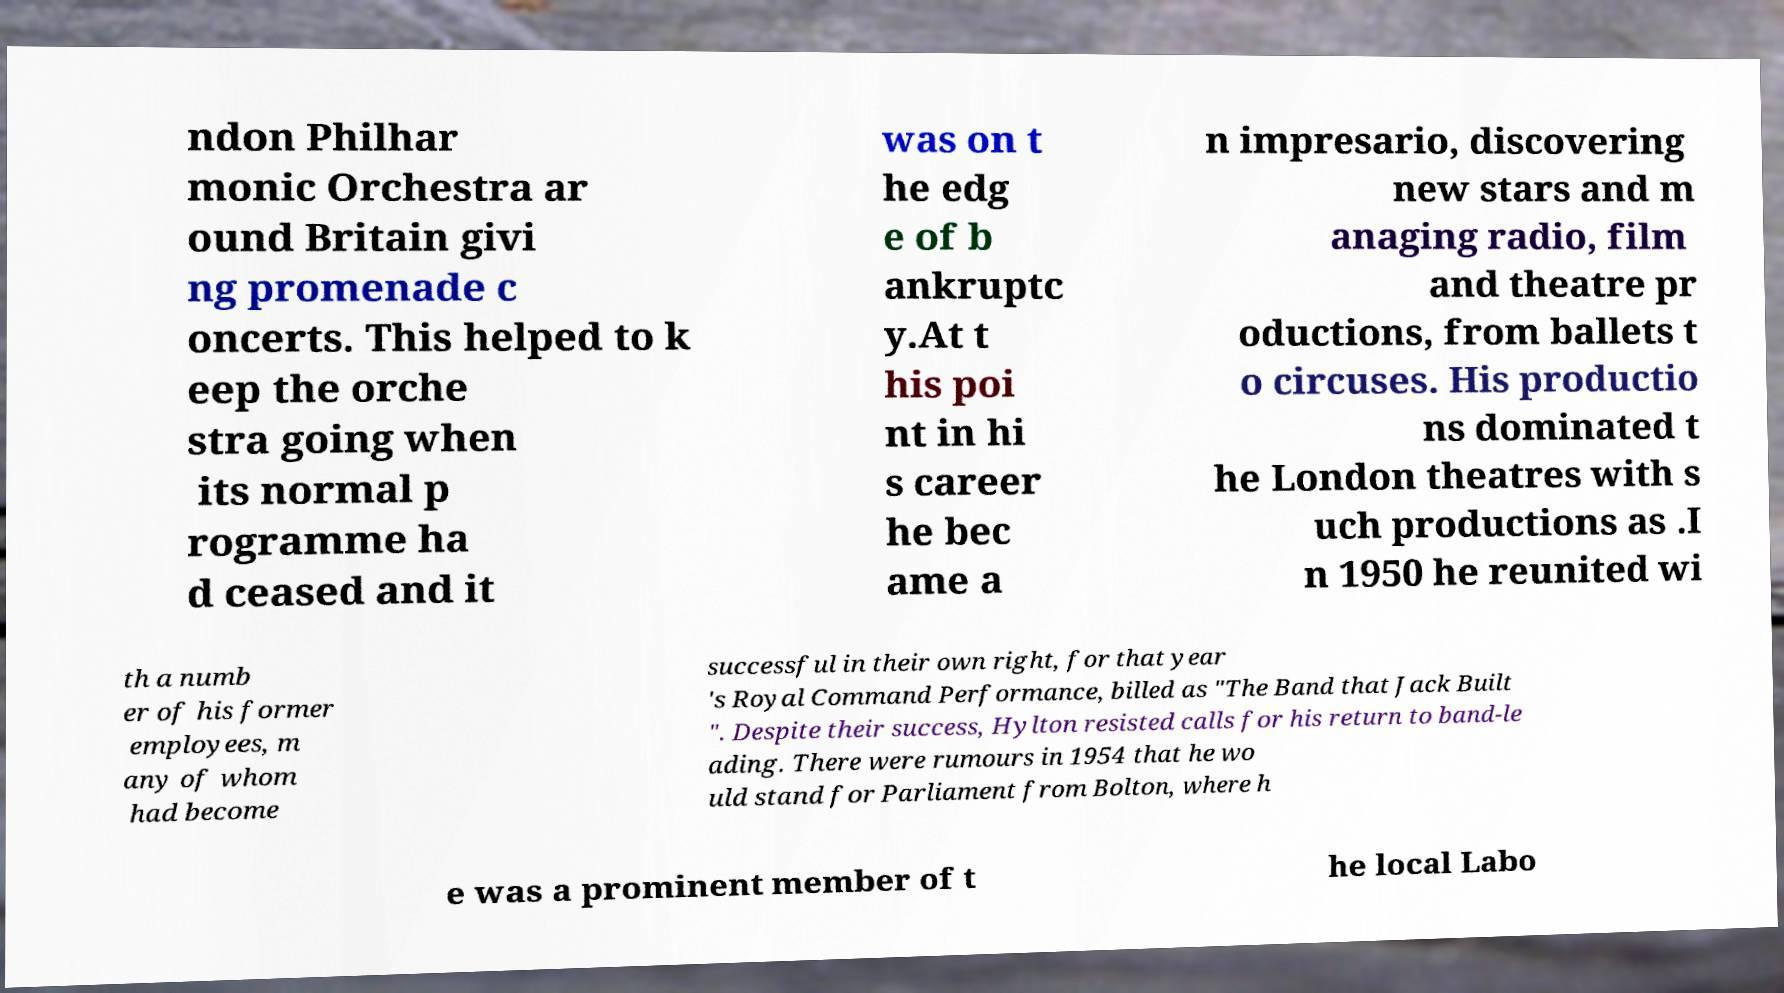I need the written content from this picture converted into text. Can you do that? ndon Philhar monic Orchestra ar ound Britain givi ng promenade c oncerts. This helped to k eep the orche stra going when its normal p rogramme ha d ceased and it was on t he edg e of b ankruptc y.At t his poi nt in hi s career he bec ame a n impresario, discovering new stars and m anaging radio, film and theatre pr oductions, from ballets t o circuses. His productio ns dominated t he London theatres with s uch productions as .I n 1950 he reunited wi th a numb er of his former employees, m any of whom had become successful in their own right, for that year 's Royal Command Performance, billed as "The Band that Jack Built ". Despite their success, Hylton resisted calls for his return to band-le ading. There were rumours in 1954 that he wo uld stand for Parliament from Bolton, where h e was a prominent member of t he local Labo 